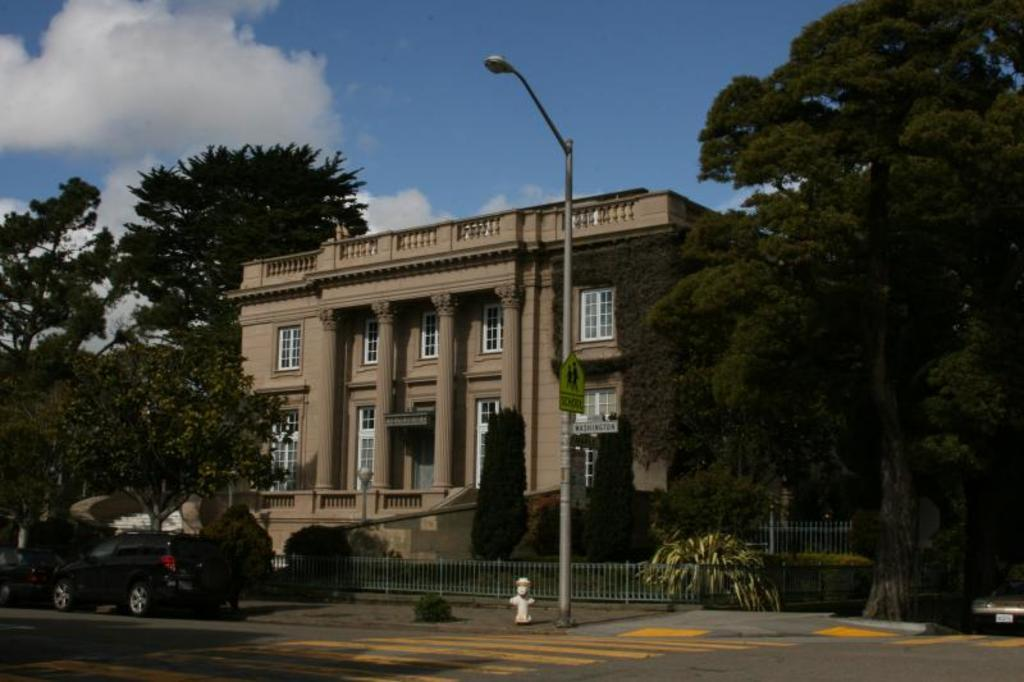What type of structure is visible in the image? There is a building in the image. What is located in front of the building? There are two cars in front of the building. What can be seen above the cars in the image? There is a street light in the image. What type of vegetation surrounds the building? There are many trees around the building. How many eggs are being held by the women in the image? There are no women or eggs present in the image. 